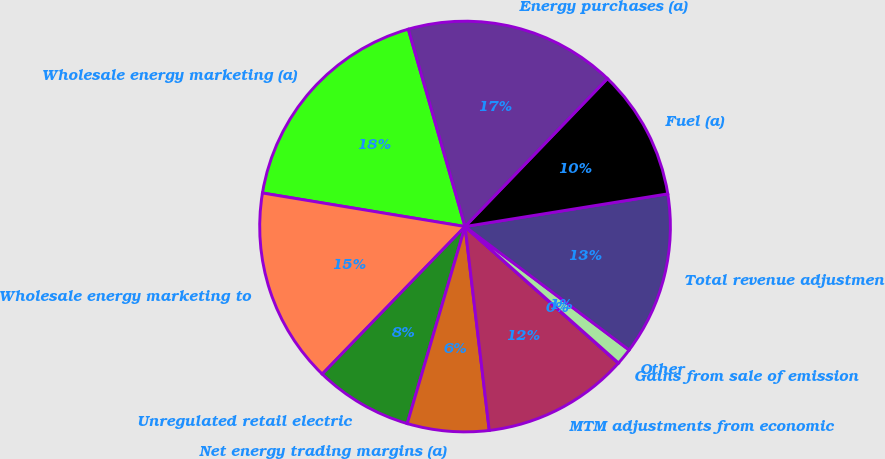Convert chart. <chart><loc_0><loc_0><loc_500><loc_500><pie_chart><fcel>Wholesale energy marketing (a)<fcel>Wholesale energy marketing to<fcel>Unregulated retail electric<fcel>Net energy trading margins (a)<fcel>MTM adjustments from economic<fcel>Gains from sale of emission<fcel>Other<fcel>Total revenue adjustments<fcel>Fuel (a)<fcel>Energy purchases (a)<nl><fcel>17.93%<fcel>15.37%<fcel>7.7%<fcel>6.42%<fcel>11.53%<fcel>0.02%<fcel>1.3%<fcel>12.81%<fcel>10.26%<fcel>16.65%<nl></chart> 